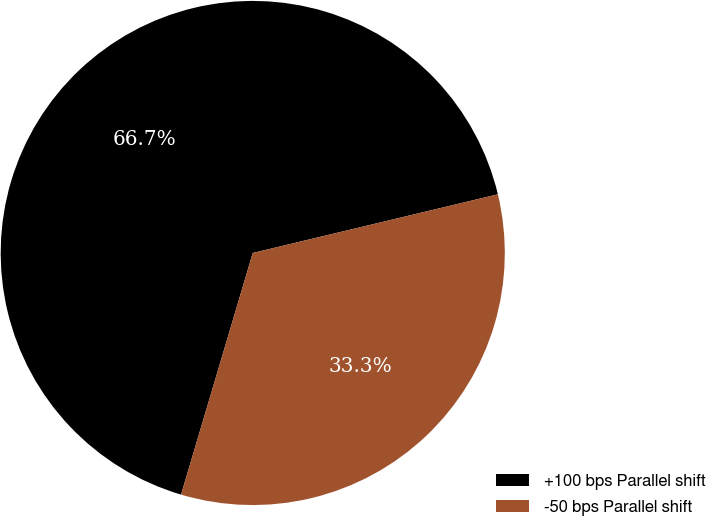<chart> <loc_0><loc_0><loc_500><loc_500><pie_chart><fcel>+100 bps Parallel shift<fcel>-50 bps Parallel shift<nl><fcel>66.67%<fcel>33.33%<nl></chart> 